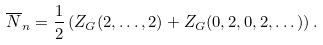Convert formula to latex. <formula><loc_0><loc_0><loc_500><loc_500>\overline { N } _ { n } = \frac { 1 } { 2 } \left ( Z _ { G } ( 2 , \dots , 2 ) + Z _ { G } ( 0 , 2 , 0 , 2 , \dots ) \right ) .</formula> 